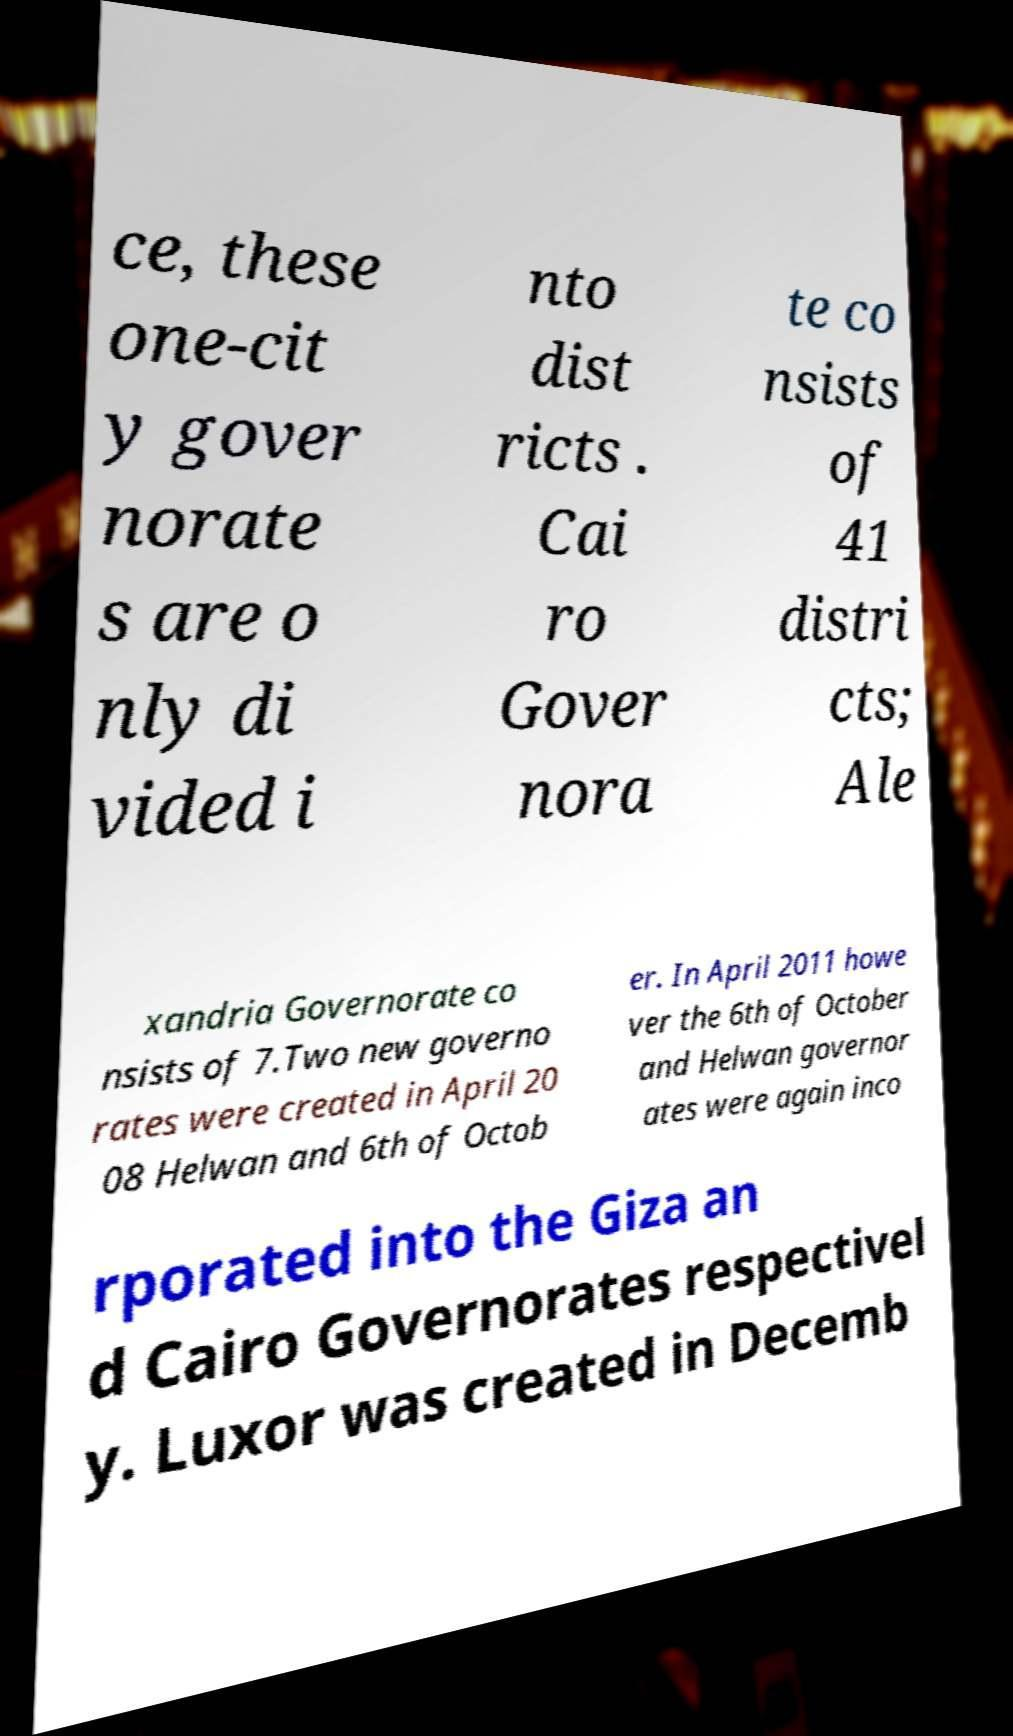For documentation purposes, I need the text within this image transcribed. Could you provide that? ce, these one-cit y gover norate s are o nly di vided i nto dist ricts . Cai ro Gover nora te co nsists of 41 distri cts; Ale xandria Governorate co nsists of 7.Two new governo rates were created in April 20 08 Helwan and 6th of Octob er. In April 2011 howe ver the 6th of October and Helwan governor ates were again inco rporated into the Giza an d Cairo Governorates respectivel y. Luxor was created in Decemb 